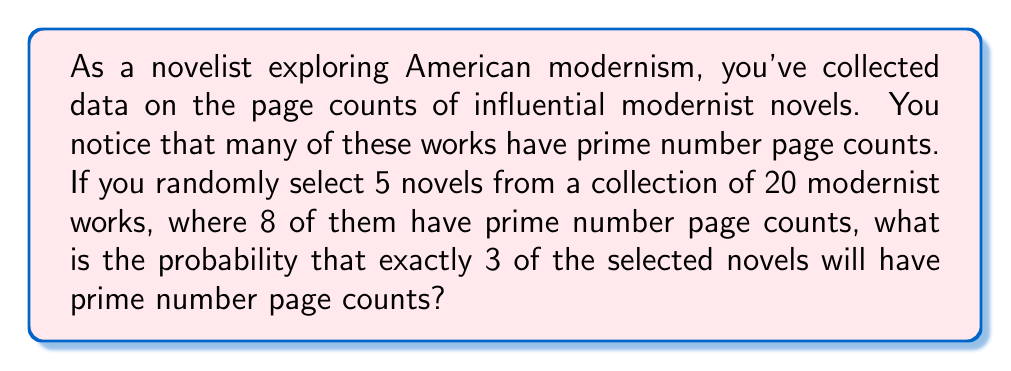Provide a solution to this math problem. To solve this problem, we'll use the hypergeometric distribution, which is appropriate for sampling without replacement from a finite population.

Let's define our variables:
$N = 20$ (total number of novels)
$K = 8$ (number of novels with prime page counts)
$n = 5$ (number of novels selected)
$k = 3$ (number of selected novels we want to have prime page counts)

The probability mass function for the hypergeometric distribution is:

$$ P(X = k) = \frac{\binom{K}{k} \binom{N-K}{n-k}}{\binom{N}{n}} $$

Where:
$\binom{a}{b}$ represents the binomial coefficient, calculated as $\frac{a!}{b!(a-b)!}$

Let's calculate each part:

1) $\binom{K}{k} = \binom{8}{3} = \frac{8!}{3!(8-3)!} = 56$

2) $\binom{N-K}{n-k} = \binom{12}{2} = \frac{12!}{2!(12-2)!} = 66$

3) $\binom{N}{n} = \binom{20}{5} = \frac{20!}{5!(20-5)!} = 15504$

Now, let's substitute these values into our probability mass function:

$$ P(X = 3) = \frac{56 \cdot 66}{15504} = \frac{3696}{15504} = \frac{231}{969} \approx 0.2384 $$
Answer: The probability is $\frac{231}{969}$ or approximately 0.2384 (23.84%). 